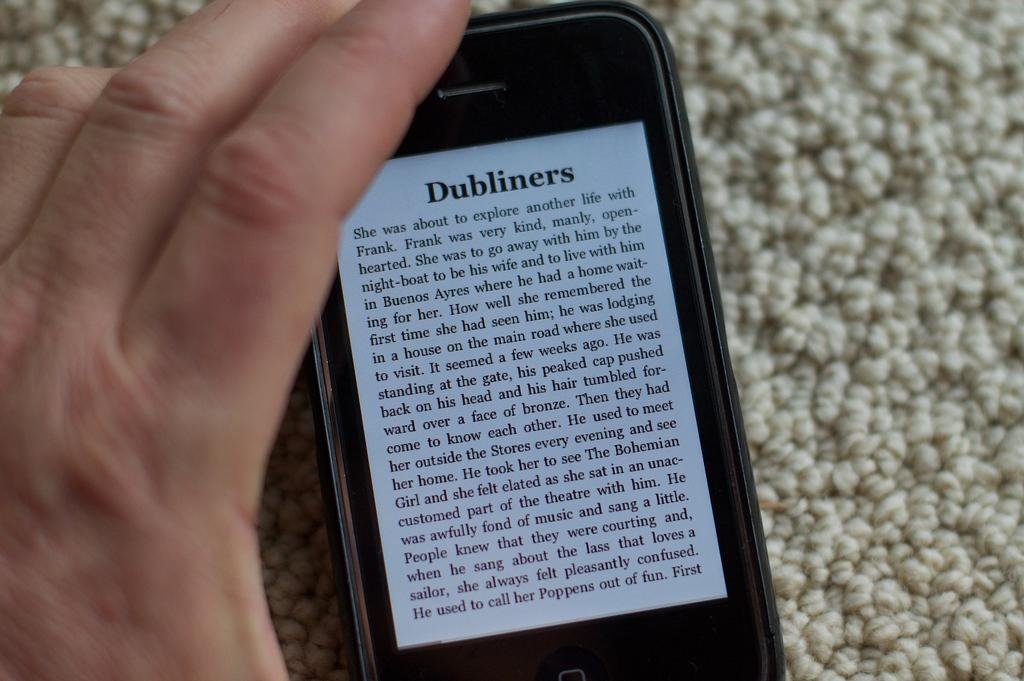<image>
Render a clear and concise summary of the photo. A page from the Dubliners appears on a portable reading device 